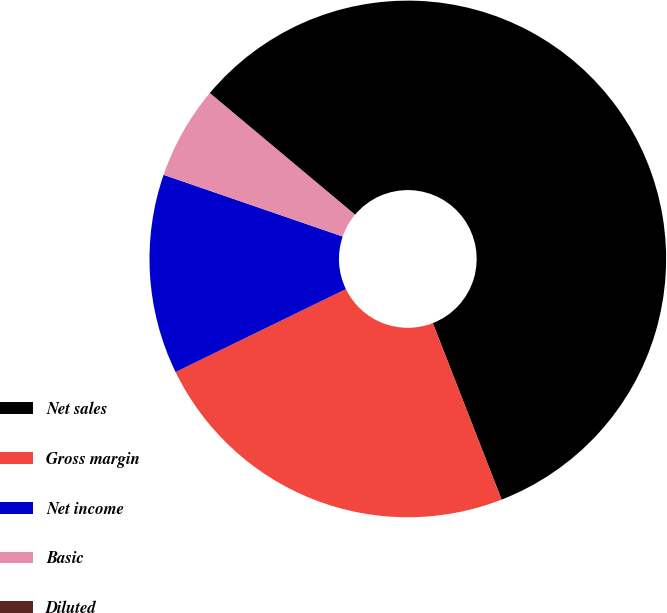Convert chart to OTSL. <chart><loc_0><loc_0><loc_500><loc_500><pie_chart><fcel>Net sales<fcel>Gross margin<fcel>Net income<fcel>Basic<fcel>Diluted<nl><fcel>57.98%<fcel>23.7%<fcel>12.49%<fcel>5.81%<fcel>0.01%<nl></chart> 